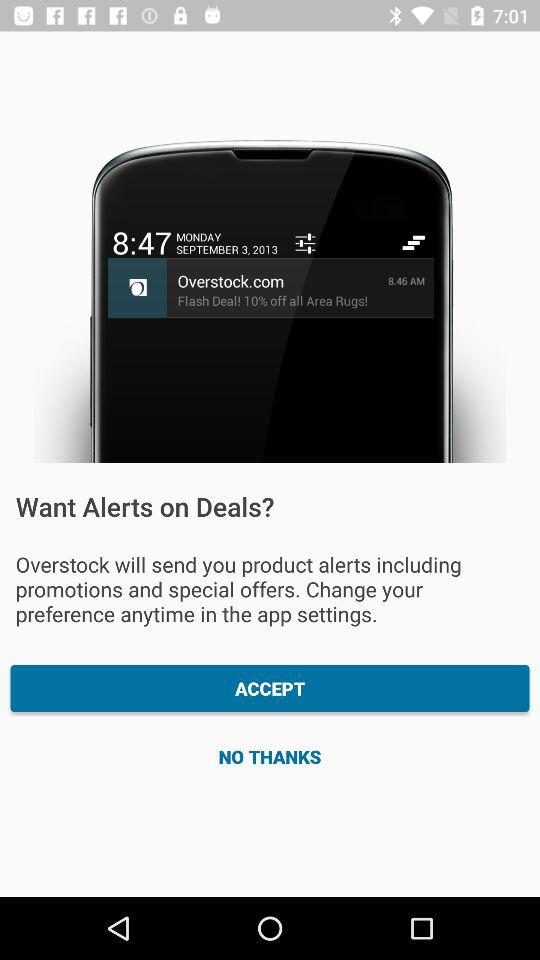What is the date on the screen? The date on the screen is Monday, September 3, 2013. 